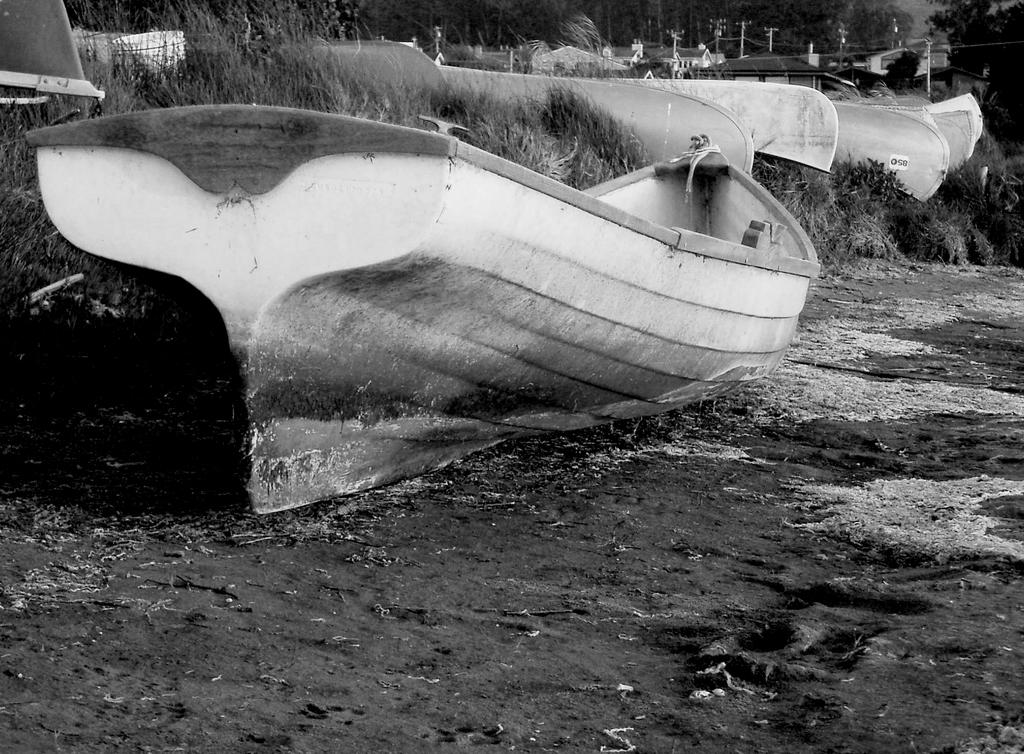What is the main subject of the image? There is a boat in the image. Where is the boat located? The boat is on the land. What type of vegetation can be seen on the ground? There is grass on the ground. What can be seen in the background of the image? There are trees in the background of the image. What is the color scheme of the image? The image is black and white. What type of tail can be seen on the boat in the image? There is no tail present on the boat in the image. What flavor of ice cream is being served on the boat in the image? There is no ice cream or any food item present in the image. 